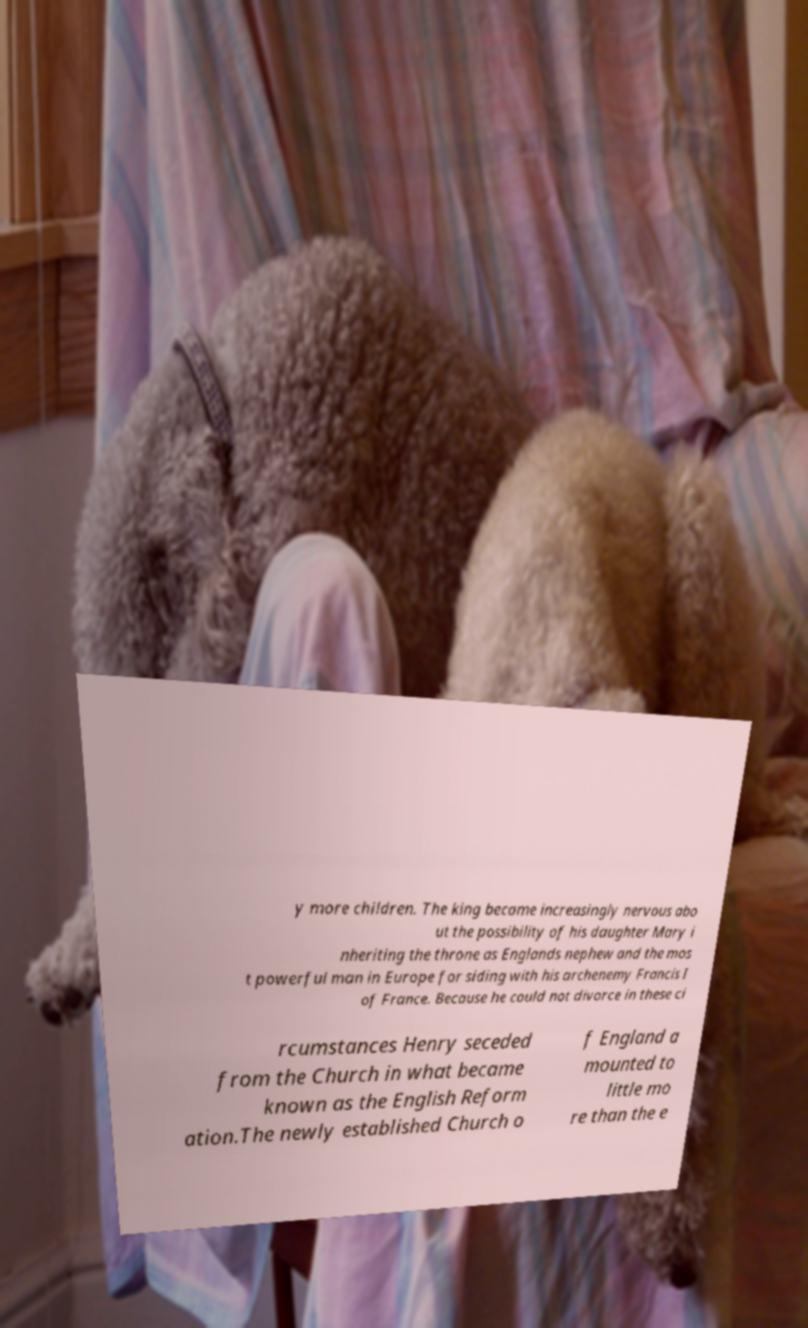Please read and relay the text visible in this image. What does it say? y more children. The king became increasingly nervous abo ut the possibility of his daughter Mary i nheriting the throne as Englands nephew and the mos t powerful man in Europe for siding with his archenemy Francis I of France. Because he could not divorce in these ci rcumstances Henry seceded from the Church in what became known as the English Reform ation.The newly established Church o f England a mounted to little mo re than the e 